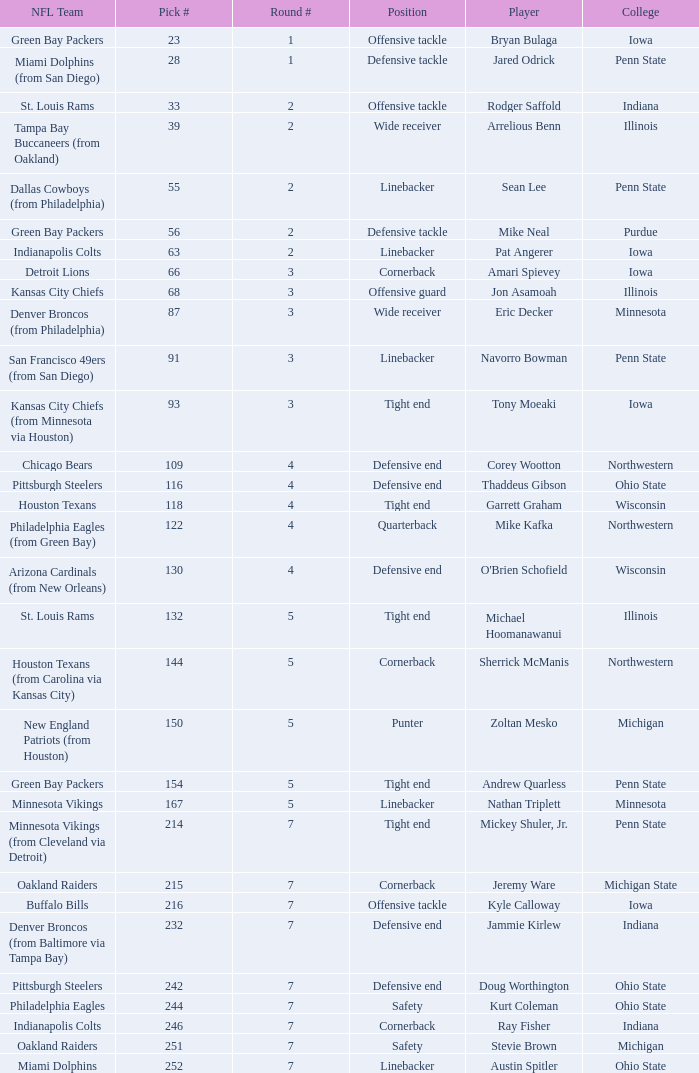What NFL team was the player with pick number 28 drafted to? Miami Dolphins (from San Diego). 